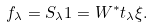Convert formula to latex. <formula><loc_0><loc_0><loc_500><loc_500>f _ { \lambda } = S _ { \lambda } 1 = W ^ { * } t _ { \lambda } \xi .</formula> 